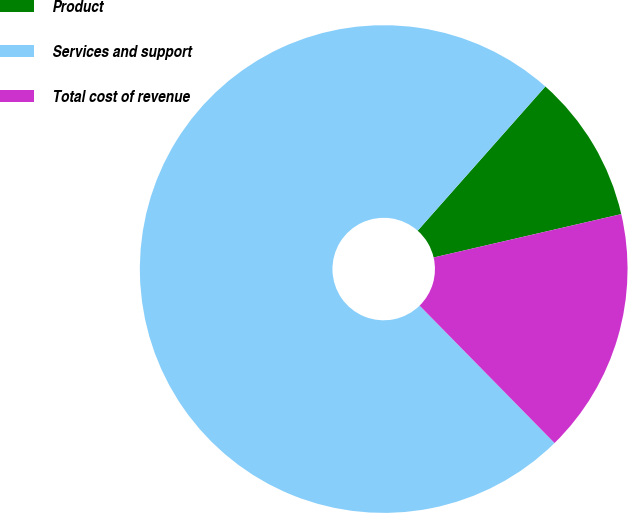Convert chart. <chart><loc_0><loc_0><loc_500><loc_500><pie_chart><fcel>Product<fcel>Services and support<fcel>Total cost of revenue<nl><fcel>9.85%<fcel>73.89%<fcel>16.26%<nl></chart> 